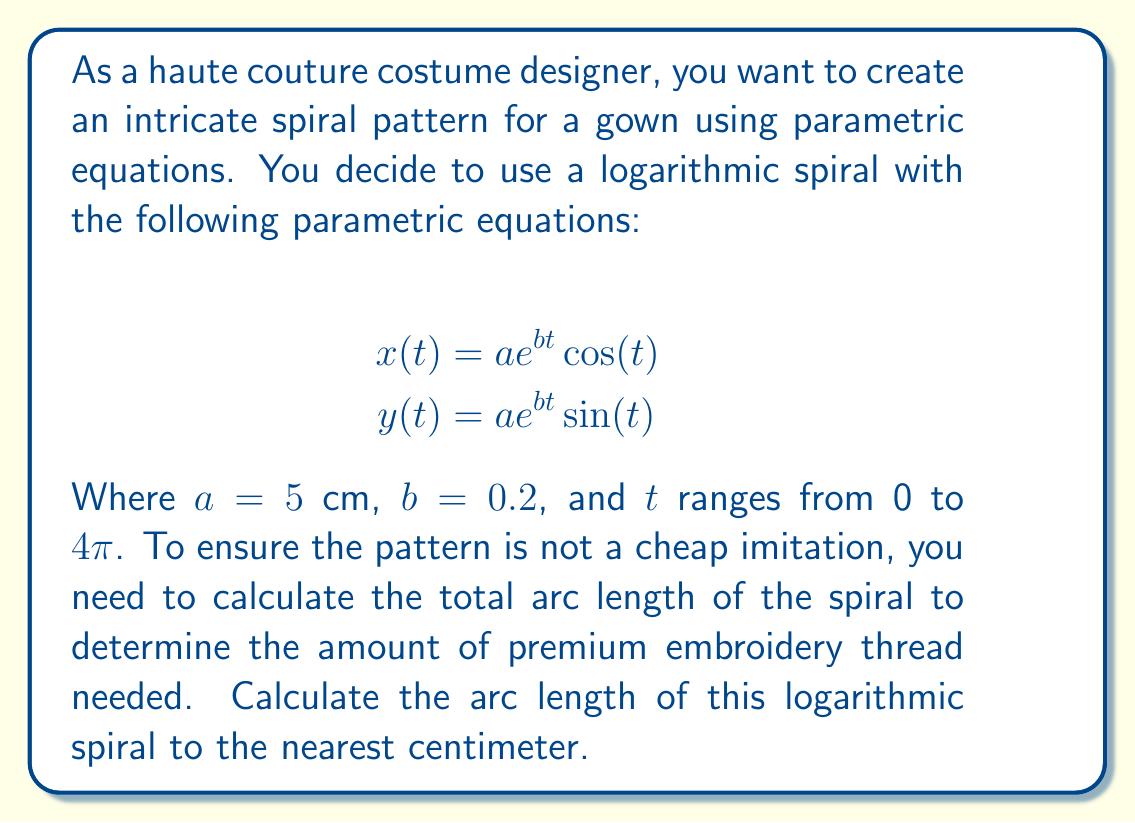What is the answer to this math problem? To find the arc length of a parametric curve, we use the following formula:

$$L = \int_{t_1}^{t_2} \sqrt{\left(\frac{dx}{dt}\right)^2 + \left(\frac{dy}{dt}\right)^2} dt$$

First, we need to find $\frac{dx}{dt}$ and $\frac{dy}{dt}$:

$$\frac{dx}{dt} = ae^{bt}(b\cos(t) - \sin(t))$$
$$\frac{dy}{dt} = ae^{bt}(b\sin(t) + \cos(t))$$

Now, let's substitute these into the arc length formula:

$$L = \int_{0}^{4\pi} \sqrt{(ae^{bt}(b\cos(t) - \sin(t)))^2 + (ae^{bt}(b\sin(t) + \cos(t)))^2} dt$$

Simplifying the expression under the square root:

$$L = \int_{0}^{4\pi} \sqrt{a^2e^{2bt}((b\cos(t) - \sin(t))^2 + (b\sin(t) + \cos(t))^2)} dt$$

$$L = \int_{0}^{4\pi} \sqrt{a^2e^{2bt}(b^2\cos^2(t) - 2b\cos(t)\sin(t) + \sin^2(t) + b^2\sin^2(t) + 2b\sin(t)\cos(t) + \cos^2(t))} dt$$

$$L = \int_{0}^{4\pi} \sqrt{a^2e^{2bt}(b^2(\cos^2(t) + \sin^2(t)) + (\sin^2(t) + \cos^2(t)))} dt$$

Since $\sin^2(t) + \cos^2(t) = 1$, we can simplify further:

$$L = \int_{0}^{4\pi} \sqrt{a^2e^{2bt}(b^2 + 1)} dt$$

$$L = a\sqrt{b^2 + 1} \int_{0}^{4\pi} e^{bt} dt$$

Now we can evaluate the integral:

$$L = a\sqrt{b^2 + 1} \left[\frac{1}{b}e^{bt}\right]_{0}^{4\pi}$$

$$L = \frac{a\sqrt{b^2 + 1}}{b} (e^{4\pi b} - 1)$$

Substituting the given values $a = 5$ cm, $b = 0.2$:

$$L = \frac{5\sqrt{0.2^2 + 1}}{0.2} (e^{4\pi (0.2)} - 1)$$

Using a calculator to evaluate this expression and rounding to the nearest centimeter:

$$L \approx 283 \text{ cm}$$
Answer: 283 cm 